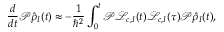<formula> <loc_0><loc_0><loc_500><loc_500>\frac { d } { d t } { \mathcal { P } } \hat { \rho } _ { I } ( t ) \approx - \frac { 1 } { \hbar { ^ } { 2 } } \int _ { 0 } ^ { t } { \mathcal { P } } { \mathcal { L } } _ { c , I } ( t ) { \mathcal { L } } _ { c , I } ( \tau ) { \mathcal { P } } \hat { \rho } _ { I } ( t ) ,</formula> 